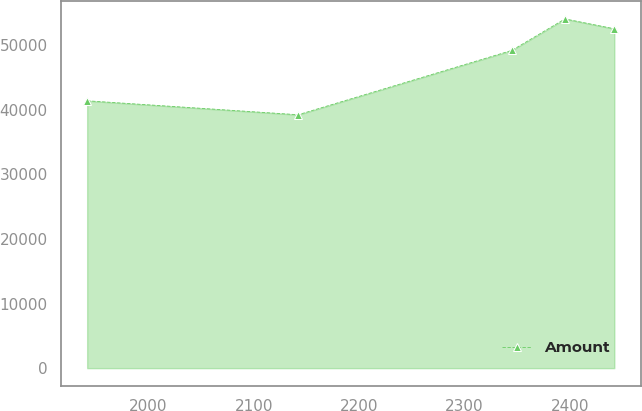Convert chart to OTSL. <chart><loc_0><loc_0><loc_500><loc_500><line_chart><ecel><fcel>Amount<nl><fcel>1941.77<fcel>41374.8<nl><fcel>2142.17<fcel>39214.8<nl><fcel>2345.05<fcel>49169.7<nl><fcel>2395.57<fcel>54045<nl><fcel>2442.43<fcel>52518.6<nl></chart> 